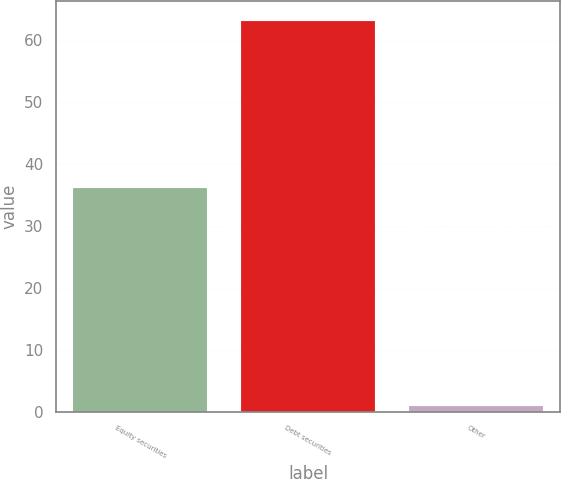<chart> <loc_0><loc_0><loc_500><loc_500><bar_chart><fcel>Equity securities<fcel>Debt securities<fcel>Other<nl><fcel>36<fcel>63<fcel>1<nl></chart> 